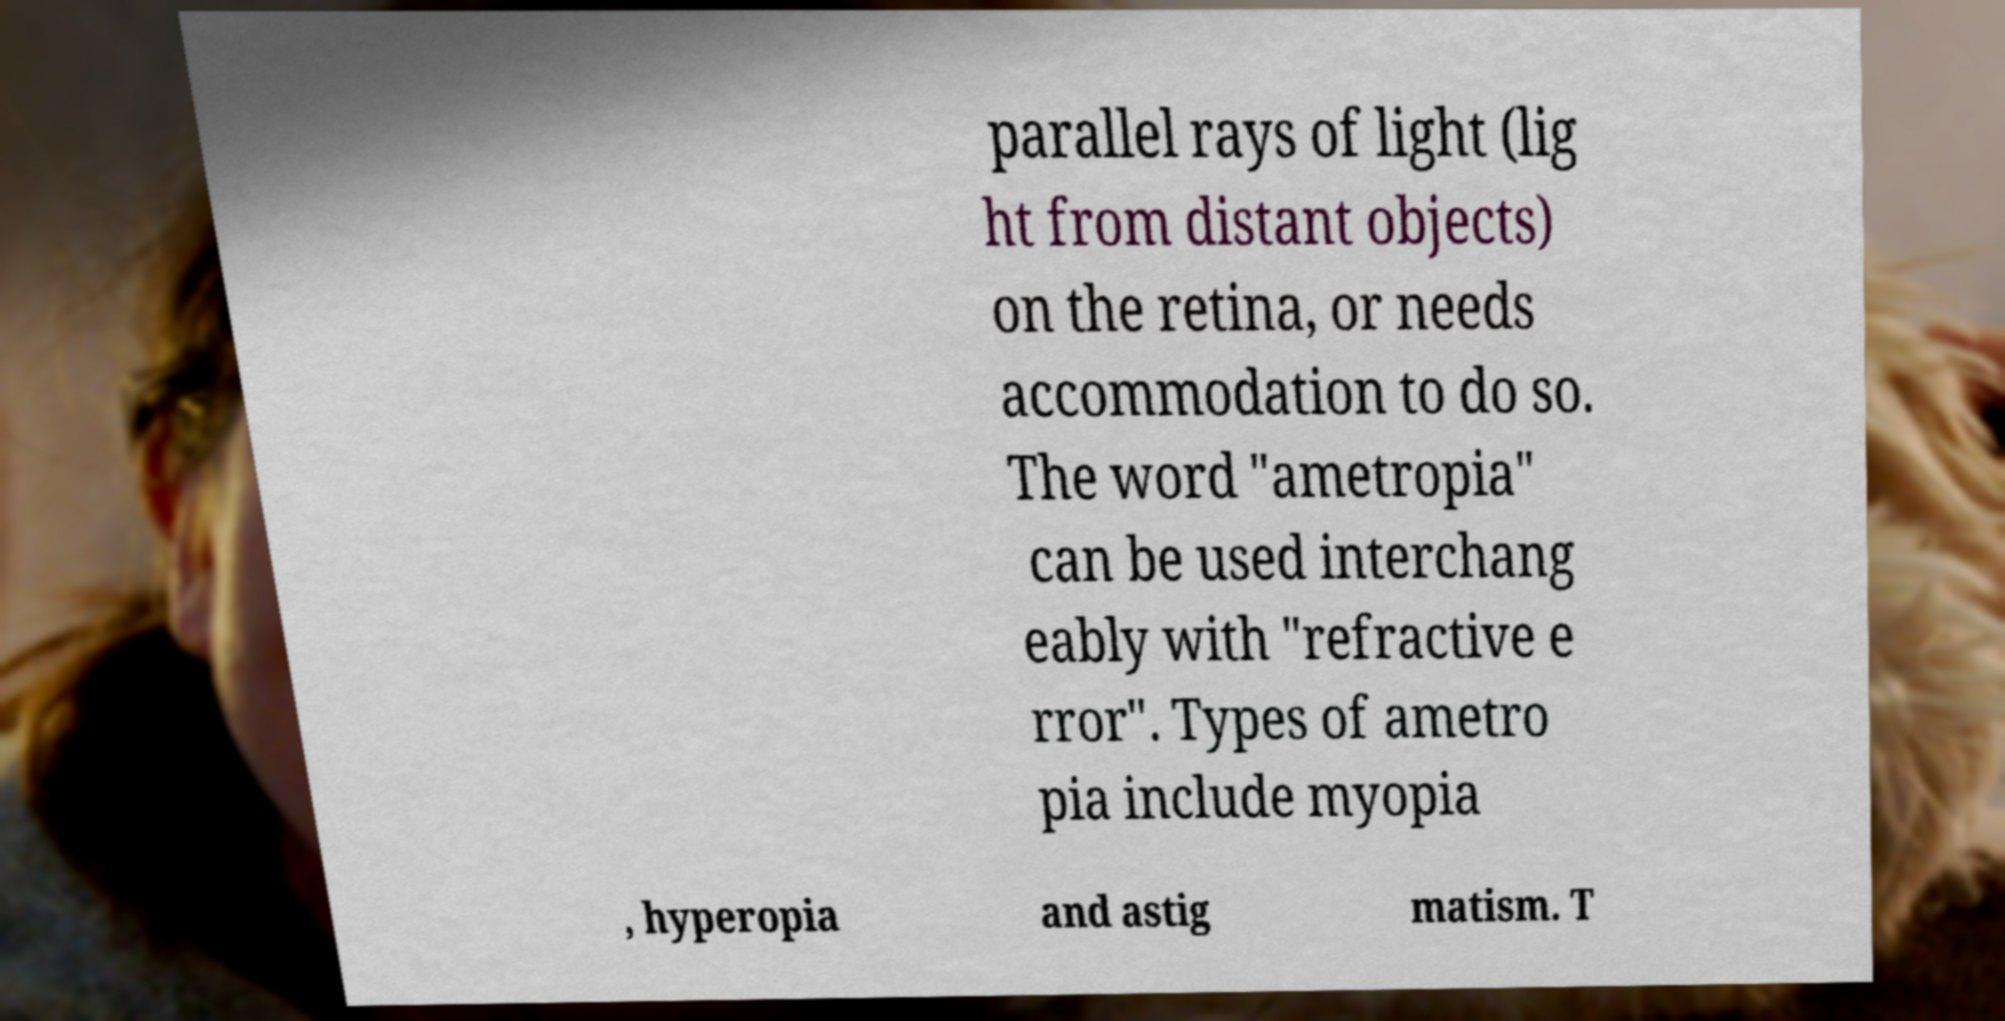Can you read and provide the text displayed in the image?This photo seems to have some interesting text. Can you extract and type it out for me? parallel rays of light (lig ht from distant objects) on the retina, or needs accommodation to do so. The word "ametropia" can be used interchang eably with "refractive e rror". Types of ametro pia include myopia , hyperopia and astig matism. T 